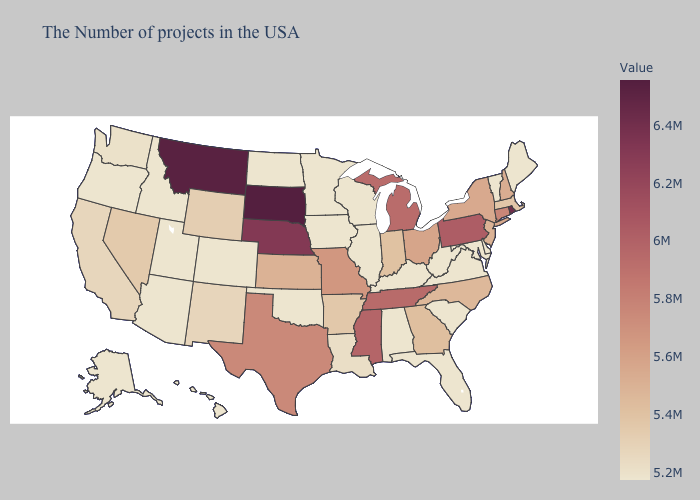Does Kentucky have the lowest value in the USA?
Write a very short answer. Yes. Does Oklahoma have the lowest value in the South?
Answer briefly. Yes. Does Wyoming have the lowest value in the West?
Keep it brief. No. Does Connecticut have a higher value than Nevada?
Short answer required. Yes. Does the map have missing data?
Keep it brief. No. Among the states that border Montana , which have the lowest value?
Write a very short answer. North Dakota, Idaho. Is the legend a continuous bar?
Answer briefly. Yes. 